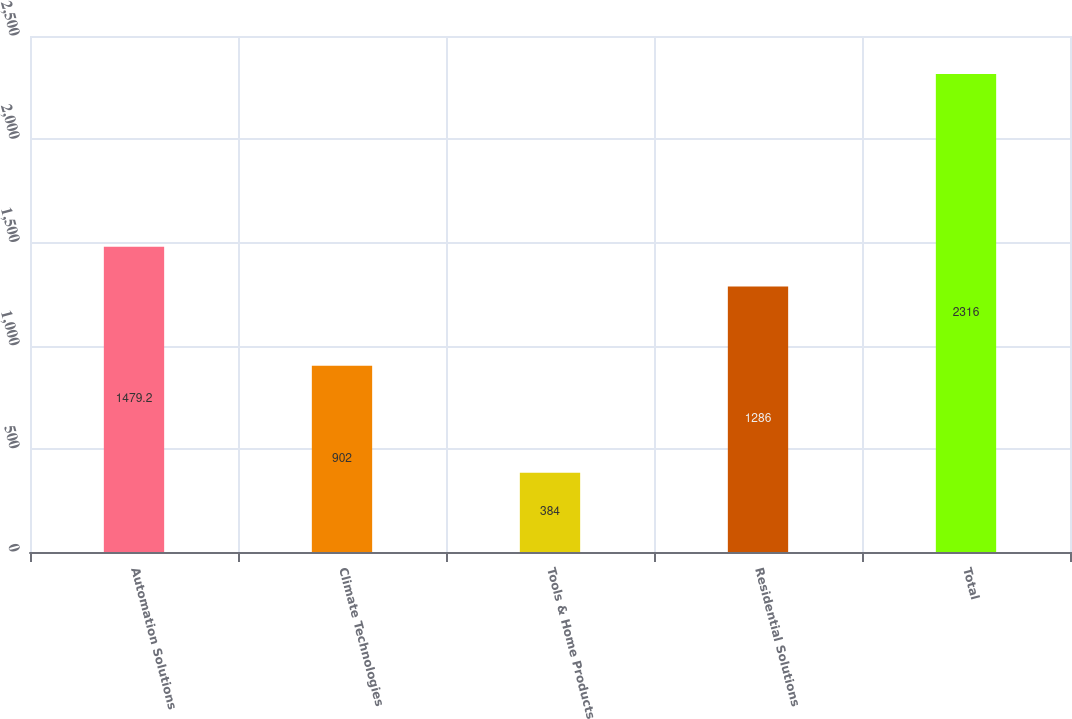Convert chart. <chart><loc_0><loc_0><loc_500><loc_500><bar_chart><fcel>Automation Solutions<fcel>Climate Technologies<fcel>Tools & Home Products<fcel>Residential Solutions<fcel>Total<nl><fcel>1479.2<fcel>902<fcel>384<fcel>1286<fcel>2316<nl></chart> 